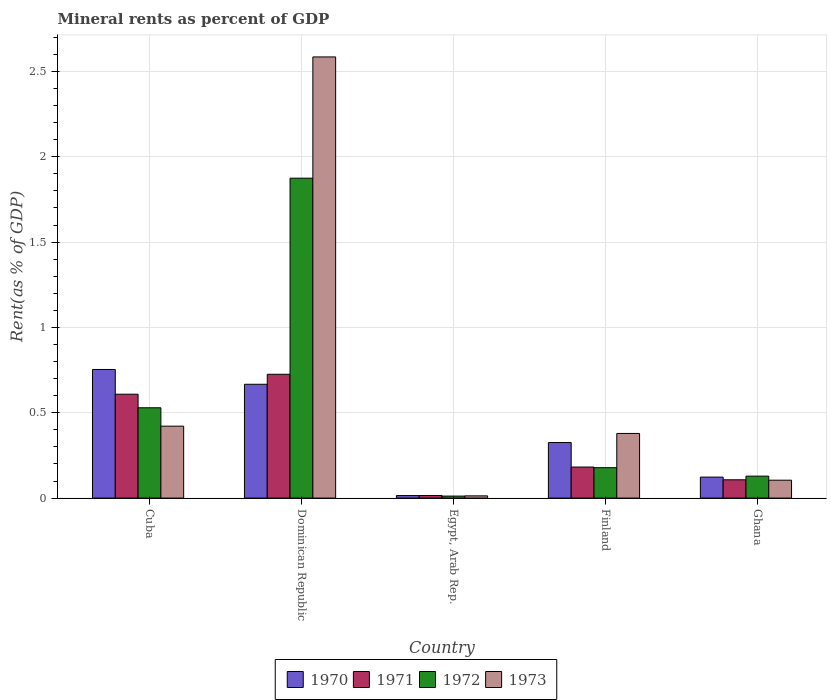How many bars are there on the 3rd tick from the left?
Your response must be concise. 4. How many bars are there on the 3rd tick from the right?
Your answer should be compact. 4. What is the label of the 2nd group of bars from the left?
Give a very brief answer. Dominican Republic. What is the mineral rent in 1972 in Cuba?
Keep it short and to the point. 0.53. Across all countries, what is the maximum mineral rent in 1970?
Offer a very short reply. 0.75. Across all countries, what is the minimum mineral rent in 1971?
Your response must be concise. 0.02. In which country was the mineral rent in 1971 maximum?
Give a very brief answer. Dominican Republic. In which country was the mineral rent in 1973 minimum?
Your answer should be very brief. Egypt, Arab Rep. What is the total mineral rent in 1972 in the graph?
Ensure brevity in your answer.  2.72. What is the difference between the mineral rent in 1970 in Finland and that in Ghana?
Your answer should be very brief. 0.2. What is the difference between the mineral rent in 1973 in Dominican Republic and the mineral rent in 1971 in Finland?
Offer a very short reply. 2.4. What is the average mineral rent in 1972 per country?
Offer a very short reply. 0.54. What is the difference between the mineral rent of/in 1973 and mineral rent of/in 1972 in Ghana?
Ensure brevity in your answer.  -0.02. In how many countries, is the mineral rent in 1972 greater than 0.5 %?
Keep it short and to the point. 2. What is the ratio of the mineral rent in 1972 in Egypt, Arab Rep. to that in Finland?
Ensure brevity in your answer.  0.07. What is the difference between the highest and the second highest mineral rent in 1971?
Provide a short and direct response. 0.12. What is the difference between the highest and the lowest mineral rent in 1970?
Provide a short and direct response. 0.74. Is the sum of the mineral rent in 1970 in Dominican Republic and Ghana greater than the maximum mineral rent in 1971 across all countries?
Your answer should be compact. Yes. Is it the case that in every country, the sum of the mineral rent in 1972 and mineral rent in 1971 is greater than the sum of mineral rent in 1973 and mineral rent in 1970?
Provide a short and direct response. No. Is it the case that in every country, the sum of the mineral rent in 1970 and mineral rent in 1973 is greater than the mineral rent in 1971?
Make the answer very short. Yes. How many bars are there?
Provide a succinct answer. 20. What is the difference between two consecutive major ticks on the Y-axis?
Give a very brief answer. 0.5. Where does the legend appear in the graph?
Offer a very short reply. Bottom center. How many legend labels are there?
Your answer should be very brief. 4. How are the legend labels stacked?
Provide a short and direct response. Horizontal. What is the title of the graph?
Make the answer very short. Mineral rents as percent of GDP. What is the label or title of the Y-axis?
Your answer should be compact. Rent(as % of GDP). What is the Rent(as % of GDP) in 1970 in Cuba?
Give a very brief answer. 0.75. What is the Rent(as % of GDP) in 1971 in Cuba?
Provide a short and direct response. 0.61. What is the Rent(as % of GDP) of 1972 in Cuba?
Offer a terse response. 0.53. What is the Rent(as % of GDP) of 1973 in Cuba?
Your answer should be very brief. 0.42. What is the Rent(as % of GDP) in 1970 in Dominican Republic?
Provide a succinct answer. 0.67. What is the Rent(as % of GDP) of 1971 in Dominican Republic?
Your answer should be very brief. 0.73. What is the Rent(as % of GDP) in 1972 in Dominican Republic?
Your answer should be compact. 1.87. What is the Rent(as % of GDP) in 1973 in Dominican Republic?
Offer a very short reply. 2.59. What is the Rent(as % of GDP) in 1970 in Egypt, Arab Rep.?
Ensure brevity in your answer.  0.01. What is the Rent(as % of GDP) of 1971 in Egypt, Arab Rep.?
Ensure brevity in your answer.  0.02. What is the Rent(as % of GDP) of 1972 in Egypt, Arab Rep.?
Your response must be concise. 0.01. What is the Rent(as % of GDP) of 1973 in Egypt, Arab Rep.?
Ensure brevity in your answer.  0.01. What is the Rent(as % of GDP) of 1970 in Finland?
Offer a very short reply. 0.33. What is the Rent(as % of GDP) of 1971 in Finland?
Make the answer very short. 0.18. What is the Rent(as % of GDP) of 1972 in Finland?
Offer a very short reply. 0.18. What is the Rent(as % of GDP) in 1973 in Finland?
Provide a short and direct response. 0.38. What is the Rent(as % of GDP) of 1970 in Ghana?
Your response must be concise. 0.12. What is the Rent(as % of GDP) of 1971 in Ghana?
Provide a short and direct response. 0.11. What is the Rent(as % of GDP) of 1972 in Ghana?
Ensure brevity in your answer.  0.13. What is the Rent(as % of GDP) of 1973 in Ghana?
Your response must be concise. 0.1. Across all countries, what is the maximum Rent(as % of GDP) of 1970?
Keep it short and to the point. 0.75. Across all countries, what is the maximum Rent(as % of GDP) in 1971?
Make the answer very short. 0.73. Across all countries, what is the maximum Rent(as % of GDP) in 1972?
Your answer should be very brief. 1.87. Across all countries, what is the maximum Rent(as % of GDP) in 1973?
Your answer should be very brief. 2.59. Across all countries, what is the minimum Rent(as % of GDP) of 1970?
Keep it short and to the point. 0.01. Across all countries, what is the minimum Rent(as % of GDP) of 1971?
Offer a very short reply. 0.02. Across all countries, what is the minimum Rent(as % of GDP) of 1972?
Your answer should be compact. 0.01. Across all countries, what is the minimum Rent(as % of GDP) of 1973?
Keep it short and to the point. 0.01. What is the total Rent(as % of GDP) in 1970 in the graph?
Offer a terse response. 1.88. What is the total Rent(as % of GDP) in 1971 in the graph?
Your answer should be very brief. 1.64. What is the total Rent(as % of GDP) of 1972 in the graph?
Offer a very short reply. 2.72. What is the total Rent(as % of GDP) in 1973 in the graph?
Give a very brief answer. 3.5. What is the difference between the Rent(as % of GDP) in 1970 in Cuba and that in Dominican Republic?
Ensure brevity in your answer.  0.09. What is the difference between the Rent(as % of GDP) of 1971 in Cuba and that in Dominican Republic?
Provide a short and direct response. -0.12. What is the difference between the Rent(as % of GDP) of 1972 in Cuba and that in Dominican Republic?
Your answer should be compact. -1.35. What is the difference between the Rent(as % of GDP) of 1973 in Cuba and that in Dominican Republic?
Ensure brevity in your answer.  -2.16. What is the difference between the Rent(as % of GDP) in 1970 in Cuba and that in Egypt, Arab Rep.?
Keep it short and to the point. 0.74. What is the difference between the Rent(as % of GDP) of 1971 in Cuba and that in Egypt, Arab Rep.?
Give a very brief answer. 0.59. What is the difference between the Rent(as % of GDP) in 1972 in Cuba and that in Egypt, Arab Rep.?
Provide a succinct answer. 0.52. What is the difference between the Rent(as % of GDP) in 1973 in Cuba and that in Egypt, Arab Rep.?
Your response must be concise. 0.41. What is the difference between the Rent(as % of GDP) in 1970 in Cuba and that in Finland?
Provide a succinct answer. 0.43. What is the difference between the Rent(as % of GDP) in 1971 in Cuba and that in Finland?
Provide a short and direct response. 0.43. What is the difference between the Rent(as % of GDP) of 1972 in Cuba and that in Finland?
Provide a short and direct response. 0.35. What is the difference between the Rent(as % of GDP) in 1973 in Cuba and that in Finland?
Offer a terse response. 0.04. What is the difference between the Rent(as % of GDP) of 1970 in Cuba and that in Ghana?
Make the answer very short. 0.63. What is the difference between the Rent(as % of GDP) in 1971 in Cuba and that in Ghana?
Give a very brief answer. 0.5. What is the difference between the Rent(as % of GDP) of 1972 in Cuba and that in Ghana?
Keep it short and to the point. 0.4. What is the difference between the Rent(as % of GDP) of 1973 in Cuba and that in Ghana?
Make the answer very short. 0.32. What is the difference between the Rent(as % of GDP) of 1970 in Dominican Republic and that in Egypt, Arab Rep.?
Provide a short and direct response. 0.65. What is the difference between the Rent(as % of GDP) of 1971 in Dominican Republic and that in Egypt, Arab Rep.?
Your answer should be very brief. 0.71. What is the difference between the Rent(as % of GDP) of 1972 in Dominican Republic and that in Egypt, Arab Rep.?
Keep it short and to the point. 1.86. What is the difference between the Rent(as % of GDP) in 1973 in Dominican Republic and that in Egypt, Arab Rep.?
Offer a very short reply. 2.57. What is the difference between the Rent(as % of GDP) of 1970 in Dominican Republic and that in Finland?
Your answer should be compact. 0.34. What is the difference between the Rent(as % of GDP) of 1971 in Dominican Republic and that in Finland?
Keep it short and to the point. 0.54. What is the difference between the Rent(as % of GDP) of 1972 in Dominican Republic and that in Finland?
Provide a short and direct response. 1.7. What is the difference between the Rent(as % of GDP) of 1973 in Dominican Republic and that in Finland?
Ensure brevity in your answer.  2.21. What is the difference between the Rent(as % of GDP) of 1970 in Dominican Republic and that in Ghana?
Offer a very short reply. 0.54. What is the difference between the Rent(as % of GDP) in 1971 in Dominican Republic and that in Ghana?
Your answer should be very brief. 0.62. What is the difference between the Rent(as % of GDP) of 1972 in Dominican Republic and that in Ghana?
Your answer should be compact. 1.75. What is the difference between the Rent(as % of GDP) in 1973 in Dominican Republic and that in Ghana?
Give a very brief answer. 2.48. What is the difference between the Rent(as % of GDP) of 1970 in Egypt, Arab Rep. and that in Finland?
Keep it short and to the point. -0.31. What is the difference between the Rent(as % of GDP) of 1971 in Egypt, Arab Rep. and that in Finland?
Keep it short and to the point. -0.17. What is the difference between the Rent(as % of GDP) of 1972 in Egypt, Arab Rep. and that in Finland?
Your response must be concise. -0.17. What is the difference between the Rent(as % of GDP) in 1973 in Egypt, Arab Rep. and that in Finland?
Your answer should be very brief. -0.37. What is the difference between the Rent(as % of GDP) of 1970 in Egypt, Arab Rep. and that in Ghana?
Make the answer very short. -0.11. What is the difference between the Rent(as % of GDP) of 1971 in Egypt, Arab Rep. and that in Ghana?
Provide a short and direct response. -0.09. What is the difference between the Rent(as % of GDP) of 1972 in Egypt, Arab Rep. and that in Ghana?
Give a very brief answer. -0.12. What is the difference between the Rent(as % of GDP) of 1973 in Egypt, Arab Rep. and that in Ghana?
Give a very brief answer. -0.09. What is the difference between the Rent(as % of GDP) of 1970 in Finland and that in Ghana?
Give a very brief answer. 0.2. What is the difference between the Rent(as % of GDP) of 1971 in Finland and that in Ghana?
Keep it short and to the point. 0.07. What is the difference between the Rent(as % of GDP) in 1972 in Finland and that in Ghana?
Offer a very short reply. 0.05. What is the difference between the Rent(as % of GDP) of 1973 in Finland and that in Ghana?
Give a very brief answer. 0.27. What is the difference between the Rent(as % of GDP) of 1970 in Cuba and the Rent(as % of GDP) of 1971 in Dominican Republic?
Give a very brief answer. 0.03. What is the difference between the Rent(as % of GDP) in 1970 in Cuba and the Rent(as % of GDP) in 1972 in Dominican Republic?
Provide a short and direct response. -1.12. What is the difference between the Rent(as % of GDP) of 1970 in Cuba and the Rent(as % of GDP) of 1973 in Dominican Republic?
Ensure brevity in your answer.  -1.83. What is the difference between the Rent(as % of GDP) in 1971 in Cuba and the Rent(as % of GDP) in 1972 in Dominican Republic?
Your answer should be very brief. -1.27. What is the difference between the Rent(as % of GDP) of 1971 in Cuba and the Rent(as % of GDP) of 1973 in Dominican Republic?
Provide a short and direct response. -1.98. What is the difference between the Rent(as % of GDP) of 1972 in Cuba and the Rent(as % of GDP) of 1973 in Dominican Republic?
Offer a very short reply. -2.06. What is the difference between the Rent(as % of GDP) of 1970 in Cuba and the Rent(as % of GDP) of 1971 in Egypt, Arab Rep.?
Your response must be concise. 0.74. What is the difference between the Rent(as % of GDP) of 1970 in Cuba and the Rent(as % of GDP) of 1972 in Egypt, Arab Rep.?
Keep it short and to the point. 0.74. What is the difference between the Rent(as % of GDP) in 1970 in Cuba and the Rent(as % of GDP) in 1973 in Egypt, Arab Rep.?
Keep it short and to the point. 0.74. What is the difference between the Rent(as % of GDP) in 1971 in Cuba and the Rent(as % of GDP) in 1972 in Egypt, Arab Rep.?
Keep it short and to the point. 0.6. What is the difference between the Rent(as % of GDP) in 1971 in Cuba and the Rent(as % of GDP) in 1973 in Egypt, Arab Rep.?
Give a very brief answer. 0.6. What is the difference between the Rent(as % of GDP) in 1972 in Cuba and the Rent(as % of GDP) in 1973 in Egypt, Arab Rep.?
Give a very brief answer. 0.52. What is the difference between the Rent(as % of GDP) in 1970 in Cuba and the Rent(as % of GDP) in 1971 in Finland?
Ensure brevity in your answer.  0.57. What is the difference between the Rent(as % of GDP) in 1970 in Cuba and the Rent(as % of GDP) in 1972 in Finland?
Your response must be concise. 0.58. What is the difference between the Rent(as % of GDP) of 1970 in Cuba and the Rent(as % of GDP) of 1973 in Finland?
Offer a very short reply. 0.37. What is the difference between the Rent(as % of GDP) of 1971 in Cuba and the Rent(as % of GDP) of 1972 in Finland?
Keep it short and to the point. 0.43. What is the difference between the Rent(as % of GDP) in 1971 in Cuba and the Rent(as % of GDP) in 1973 in Finland?
Provide a short and direct response. 0.23. What is the difference between the Rent(as % of GDP) of 1972 in Cuba and the Rent(as % of GDP) of 1973 in Finland?
Offer a terse response. 0.15. What is the difference between the Rent(as % of GDP) in 1970 in Cuba and the Rent(as % of GDP) in 1971 in Ghana?
Ensure brevity in your answer.  0.65. What is the difference between the Rent(as % of GDP) of 1970 in Cuba and the Rent(as % of GDP) of 1973 in Ghana?
Offer a terse response. 0.65. What is the difference between the Rent(as % of GDP) of 1971 in Cuba and the Rent(as % of GDP) of 1972 in Ghana?
Make the answer very short. 0.48. What is the difference between the Rent(as % of GDP) in 1971 in Cuba and the Rent(as % of GDP) in 1973 in Ghana?
Your answer should be compact. 0.5. What is the difference between the Rent(as % of GDP) in 1972 in Cuba and the Rent(as % of GDP) in 1973 in Ghana?
Give a very brief answer. 0.42. What is the difference between the Rent(as % of GDP) of 1970 in Dominican Republic and the Rent(as % of GDP) of 1971 in Egypt, Arab Rep.?
Provide a short and direct response. 0.65. What is the difference between the Rent(as % of GDP) of 1970 in Dominican Republic and the Rent(as % of GDP) of 1972 in Egypt, Arab Rep.?
Your answer should be compact. 0.66. What is the difference between the Rent(as % of GDP) in 1970 in Dominican Republic and the Rent(as % of GDP) in 1973 in Egypt, Arab Rep.?
Give a very brief answer. 0.65. What is the difference between the Rent(as % of GDP) of 1971 in Dominican Republic and the Rent(as % of GDP) of 1972 in Egypt, Arab Rep.?
Keep it short and to the point. 0.71. What is the difference between the Rent(as % of GDP) in 1971 in Dominican Republic and the Rent(as % of GDP) in 1973 in Egypt, Arab Rep.?
Your answer should be very brief. 0.71. What is the difference between the Rent(as % of GDP) of 1972 in Dominican Republic and the Rent(as % of GDP) of 1973 in Egypt, Arab Rep.?
Your response must be concise. 1.86. What is the difference between the Rent(as % of GDP) of 1970 in Dominican Republic and the Rent(as % of GDP) of 1971 in Finland?
Ensure brevity in your answer.  0.48. What is the difference between the Rent(as % of GDP) of 1970 in Dominican Republic and the Rent(as % of GDP) of 1972 in Finland?
Offer a terse response. 0.49. What is the difference between the Rent(as % of GDP) of 1970 in Dominican Republic and the Rent(as % of GDP) of 1973 in Finland?
Your answer should be compact. 0.29. What is the difference between the Rent(as % of GDP) in 1971 in Dominican Republic and the Rent(as % of GDP) in 1972 in Finland?
Offer a very short reply. 0.55. What is the difference between the Rent(as % of GDP) in 1971 in Dominican Republic and the Rent(as % of GDP) in 1973 in Finland?
Make the answer very short. 0.35. What is the difference between the Rent(as % of GDP) of 1972 in Dominican Republic and the Rent(as % of GDP) of 1973 in Finland?
Your answer should be very brief. 1.5. What is the difference between the Rent(as % of GDP) in 1970 in Dominican Republic and the Rent(as % of GDP) in 1971 in Ghana?
Provide a short and direct response. 0.56. What is the difference between the Rent(as % of GDP) in 1970 in Dominican Republic and the Rent(as % of GDP) in 1972 in Ghana?
Your answer should be very brief. 0.54. What is the difference between the Rent(as % of GDP) in 1970 in Dominican Republic and the Rent(as % of GDP) in 1973 in Ghana?
Provide a short and direct response. 0.56. What is the difference between the Rent(as % of GDP) in 1971 in Dominican Republic and the Rent(as % of GDP) in 1972 in Ghana?
Your response must be concise. 0.6. What is the difference between the Rent(as % of GDP) in 1971 in Dominican Republic and the Rent(as % of GDP) in 1973 in Ghana?
Offer a very short reply. 0.62. What is the difference between the Rent(as % of GDP) of 1972 in Dominican Republic and the Rent(as % of GDP) of 1973 in Ghana?
Your answer should be compact. 1.77. What is the difference between the Rent(as % of GDP) in 1970 in Egypt, Arab Rep. and the Rent(as % of GDP) in 1971 in Finland?
Ensure brevity in your answer.  -0.17. What is the difference between the Rent(as % of GDP) in 1970 in Egypt, Arab Rep. and the Rent(as % of GDP) in 1972 in Finland?
Provide a short and direct response. -0.16. What is the difference between the Rent(as % of GDP) in 1970 in Egypt, Arab Rep. and the Rent(as % of GDP) in 1973 in Finland?
Your answer should be very brief. -0.36. What is the difference between the Rent(as % of GDP) in 1971 in Egypt, Arab Rep. and the Rent(as % of GDP) in 1972 in Finland?
Provide a short and direct response. -0.16. What is the difference between the Rent(as % of GDP) in 1971 in Egypt, Arab Rep. and the Rent(as % of GDP) in 1973 in Finland?
Keep it short and to the point. -0.36. What is the difference between the Rent(as % of GDP) of 1972 in Egypt, Arab Rep. and the Rent(as % of GDP) of 1973 in Finland?
Your response must be concise. -0.37. What is the difference between the Rent(as % of GDP) in 1970 in Egypt, Arab Rep. and the Rent(as % of GDP) in 1971 in Ghana?
Your answer should be very brief. -0.09. What is the difference between the Rent(as % of GDP) of 1970 in Egypt, Arab Rep. and the Rent(as % of GDP) of 1972 in Ghana?
Your answer should be very brief. -0.11. What is the difference between the Rent(as % of GDP) in 1970 in Egypt, Arab Rep. and the Rent(as % of GDP) in 1973 in Ghana?
Provide a succinct answer. -0.09. What is the difference between the Rent(as % of GDP) in 1971 in Egypt, Arab Rep. and the Rent(as % of GDP) in 1972 in Ghana?
Ensure brevity in your answer.  -0.11. What is the difference between the Rent(as % of GDP) of 1971 in Egypt, Arab Rep. and the Rent(as % of GDP) of 1973 in Ghana?
Provide a short and direct response. -0.09. What is the difference between the Rent(as % of GDP) in 1972 in Egypt, Arab Rep. and the Rent(as % of GDP) in 1973 in Ghana?
Your answer should be compact. -0.09. What is the difference between the Rent(as % of GDP) in 1970 in Finland and the Rent(as % of GDP) in 1971 in Ghana?
Provide a succinct answer. 0.22. What is the difference between the Rent(as % of GDP) of 1970 in Finland and the Rent(as % of GDP) of 1972 in Ghana?
Your response must be concise. 0.2. What is the difference between the Rent(as % of GDP) in 1970 in Finland and the Rent(as % of GDP) in 1973 in Ghana?
Provide a succinct answer. 0.22. What is the difference between the Rent(as % of GDP) in 1971 in Finland and the Rent(as % of GDP) in 1972 in Ghana?
Provide a succinct answer. 0.05. What is the difference between the Rent(as % of GDP) in 1971 in Finland and the Rent(as % of GDP) in 1973 in Ghana?
Your answer should be very brief. 0.08. What is the difference between the Rent(as % of GDP) of 1972 in Finland and the Rent(as % of GDP) of 1973 in Ghana?
Provide a succinct answer. 0.07. What is the average Rent(as % of GDP) of 1970 per country?
Give a very brief answer. 0.38. What is the average Rent(as % of GDP) of 1971 per country?
Keep it short and to the point. 0.33. What is the average Rent(as % of GDP) of 1972 per country?
Offer a very short reply. 0.54. What is the average Rent(as % of GDP) in 1973 per country?
Provide a succinct answer. 0.7. What is the difference between the Rent(as % of GDP) in 1970 and Rent(as % of GDP) in 1971 in Cuba?
Ensure brevity in your answer.  0.14. What is the difference between the Rent(as % of GDP) of 1970 and Rent(as % of GDP) of 1972 in Cuba?
Offer a very short reply. 0.22. What is the difference between the Rent(as % of GDP) of 1970 and Rent(as % of GDP) of 1973 in Cuba?
Keep it short and to the point. 0.33. What is the difference between the Rent(as % of GDP) in 1971 and Rent(as % of GDP) in 1972 in Cuba?
Ensure brevity in your answer.  0.08. What is the difference between the Rent(as % of GDP) of 1971 and Rent(as % of GDP) of 1973 in Cuba?
Ensure brevity in your answer.  0.19. What is the difference between the Rent(as % of GDP) in 1972 and Rent(as % of GDP) in 1973 in Cuba?
Keep it short and to the point. 0.11. What is the difference between the Rent(as % of GDP) of 1970 and Rent(as % of GDP) of 1971 in Dominican Republic?
Your answer should be very brief. -0.06. What is the difference between the Rent(as % of GDP) of 1970 and Rent(as % of GDP) of 1972 in Dominican Republic?
Make the answer very short. -1.21. What is the difference between the Rent(as % of GDP) in 1970 and Rent(as % of GDP) in 1973 in Dominican Republic?
Keep it short and to the point. -1.92. What is the difference between the Rent(as % of GDP) of 1971 and Rent(as % of GDP) of 1972 in Dominican Republic?
Your answer should be compact. -1.15. What is the difference between the Rent(as % of GDP) of 1971 and Rent(as % of GDP) of 1973 in Dominican Republic?
Offer a terse response. -1.86. What is the difference between the Rent(as % of GDP) in 1972 and Rent(as % of GDP) in 1973 in Dominican Republic?
Make the answer very short. -0.71. What is the difference between the Rent(as % of GDP) in 1970 and Rent(as % of GDP) in 1971 in Egypt, Arab Rep.?
Give a very brief answer. -0. What is the difference between the Rent(as % of GDP) of 1970 and Rent(as % of GDP) of 1972 in Egypt, Arab Rep.?
Your answer should be compact. 0. What is the difference between the Rent(as % of GDP) in 1970 and Rent(as % of GDP) in 1973 in Egypt, Arab Rep.?
Make the answer very short. 0. What is the difference between the Rent(as % of GDP) in 1971 and Rent(as % of GDP) in 1972 in Egypt, Arab Rep.?
Provide a short and direct response. 0. What is the difference between the Rent(as % of GDP) of 1971 and Rent(as % of GDP) of 1973 in Egypt, Arab Rep.?
Your response must be concise. 0. What is the difference between the Rent(as % of GDP) of 1972 and Rent(as % of GDP) of 1973 in Egypt, Arab Rep.?
Keep it short and to the point. -0. What is the difference between the Rent(as % of GDP) of 1970 and Rent(as % of GDP) of 1971 in Finland?
Ensure brevity in your answer.  0.14. What is the difference between the Rent(as % of GDP) of 1970 and Rent(as % of GDP) of 1972 in Finland?
Ensure brevity in your answer.  0.15. What is the difference between the Rent(as % of GDP) in 1970 and Rent(as % of GDP) in 1973 in Finland?
Your answer should be very brief. -0.05. What is the difference between the Rent(as % of GDP) in 1971 and Rent(as % of GDP) in 1972 in Finland?
Keep it short and to the point. 0. What is the difference between the Rent(as % of GDP) of 1971 and Rent(as % of GDP) of 1973 in Finland?
Your response must be concise. -0.2. What is the difference between the Rent(as % of GDP) in 1972 and Rent(as % of GDP) in 1973 in Finland?
Make the answer very short. -0.2. What is the difference between the Rent(as % of GDP) of 1970 and Rent(as % of GDP) of 1971 in Ghana?
Provide a succinct answer. 0.02. What is the difference between the Rent(as % of GDP) of 1970 and Rent(as % of GDP) of 1972 in Ghana?
Provide a succinct answer. -0.01. What is the difference between the Rent(as % of GDP) in 1970 and Rent(as % of GDP) in 1973 in Ghana?
Your answer should be compact. 0.02. What is the difference between the Rent(as % of GDP) of 1971 and Rent(as % of GDP) of 1972 in Ghana?
Keep it short and to the point. -0.02. What is the difference between the Rent(as % of GDP) in 1971 and Rent(as % of GDP) in 1973 in Ghana?
Make the answer very short. 0. What is the difference between the Rent(as % of GDP) of 1972 and Rent(as % of GDP) of 1973 in Ghana?
Give a very brief answer. 0.02. What is the ratio of the Rent(as % of GDP) in 1970 in Cuba to that in Dominican Republic?
Give a very brief answer. 1.13. What is the ratio of the Rent(as % of GDP) in 1971 in Cuba to that in Dominican Republic?
Ensure brevity in your answer.  0.84. What is the ratio of the Rent(as % of GDP) of 1972 in Cuba to that in Dominican Republic?
Ensure brevity in your answer.  0.28. What is the ratio of the Rent(as % of GDP) of 1973 in Cuba to that in Dominican Republic?
Provide a succinct answer. 0.16. What is the ratio of the Rent(as % of GDP) of 1970 in Cuba to that in Egypt, Arab Rep.?
Give a very brief answer. 51. What is the ratio of the Rent(as % of GDP) in 1971 in Cuba to that in Egypt, Arab Rep.?
Give a very brief answer. 40.5. What is the ratio of the Rent(as % of GDP) in 1972 in Cuba to that in Egypt, Arab Rep.?
Provide a succinct answer. 45.11. What is the ratio of the Rent(as % of GDP) of 1973 in Cuba to that in Egypt, Arab Rep.?
Your answer should be very brief. 32.3. What is the ratio of the Rent(as % of GDP) of 1970 in Cuba to that in Finland?
Offer a terse response. 2.32. What is the ratio of the Rent(as % of GDP) in 1971 in Cuba to that in Finland?
Make the answer very short. 3.34. What is the ratio of the Rent(as % of GDP) of 1972 in Cuba to that in Finland?
Ensure brevity in your answer.  2.97. What is the ratio of the Rent(as % of GDP) in 1973 in Cuba to that in Finland?
Your answer should be compact. 1.11. What is the ratio of the Rent(as % of GDP) in 1970 in Cuba to that in Ghana?
Offer a terse response. 6.13. What is the ratio of the Rent(as % of GDP) of 1971 in Cuba to that in Ghana?
Offer a terse response. 5.68. What is the ratio of the Rent(as % of GDP) in 1972 in Cuba to that in Ghana?
Offer a very short reply. 4.11. What is the ratio of the Rent(as % of GDP) of 1973 in Cuba to that in Ghana?
Your answer should be compact. 4.02. What is the ratio of the Rent(as % of GDP) of 1970 in Dominican Republic to that in Egypt, Arab Rep.?
Your answer should be compact. 45.13. What is the ratio of the Rent(as % of GDP) of 1971 in Dominican Republic to that in Egypt, Arab Rep.?
Offer a terse response. 48.27. What is the ratio of the Rent(as % of GDP) of 1972 in Dominican Republic to that in Egypt, Arab Rep.?
Your answer should be very brief. 159.8. What is the ratio of the Rent(as % of GDP) in 1973 in Dominican Republic to that in Egypt, Arab Rep.?
Ensure brevity in your answer.  198.1. What is the ratio of the Rent(as % of GDP) of 1970 in Dominican Republic to that in Finland?
Your response must be concise. 2.05. What is the ratio of the Rent(as % of GDP) of 1971 in Dominican Republic to that in Finland?
Offer a terse response. 3.99. What is the ratio of the Rent(as % of GDP) of 1972 in Dominican Republic to that in Finland?
Ensure brevity in your answer.  10.53. What is the ratio of the Rent(as % of GDP) of 1973 in Dominican Republic to that in Finland?
Your answer should be compact. 6.82. What is the ratio of the Rent(as % of GDP) of 1970 in Dominican Republic to that in Ghana?
Your answer should be very brief. 5.42. What is the ratio of the Rent(as % of GDP) in 1971 in Dominican Republic to that in Ghana?
Your response must be concise. 6.77. What is the ratio of the Rent(as % of GDP) in 1972 in Dominican Republic to that in Ghana?
Your answer should be very brief. 14.57. What is the ratio of the Rent(as % of GDP) in 1973 in Dominican Republic to that in Ghana?
Give a very brief answer. 24.64. What is the ratio of the Rent(as % of GDP) of 1970 in Egypt, Arab Rep. to that in Finland?
Keep it short and to the point. 0.05. What is the ratio of the Rent(as % of GDP) in 1971 in Egypt, Arab Rep. to that in Finland?
Your answer should be compact. 0.08. What is the ratio of the Rent(as % of GDP) in 1972 in Egypt, Arab Rep. to that in Finland?
Provide a succinct answer. 0.07. What is the ratio of the Rent(as % of GDP) in 1973 in Egypt, Arab Rep. to that in Finland?
Offer a very short reply. 0.03. What is the ratio of the Rent(as % of GDP) in 1970 in Egypt, Arab Rep. to that in Ghana?
Offer a terse response. 0.12. What is the ratio of the Rent(as % of GDP) of 1971 in Egypt, Arab Rep. to that in Ghana?
Offer a terse response. 0.14. What is the ratio of the Rent(as % of GDP) of 1972 in Egypt, Arab Rep. to that in Ghana?
Your response must be concise. 0.09. What is the ratio of the Rent(as % of GDP) in 1973 in Egypt, Arab Rep. to that in Ghana?
Give a very brief answer. 0.12. What is the ratio of the Rent(as % of GDP) of 1970 in Finland to that in Ghana?
Your answer should be very brief. 2.65. What is the ratio of the Rent(as % of GDP) in 1971 in Finland to that in Ghana?
Offer a terse response. 1.7. What is the ratio of the Rent(as % of GDP) in 1972 in Finland to that in Ghana?
Ensure brevity in your answer.  1.38. What is the ratio of the Rent(as % of GDP) of 1973 in Finland to that in Ghana?
Give a very brief answer. 3.61. What is the difference between the highest and the second highest Rent(as % of GDP) of 1970?
Provide a short and direct response. 0.09. What is the difference between the highest and the second highest Rent(as % of GDP) of 1971?
Make the answer very short. 0.12. What is the difference between the highest and the second highest Rent(as % of GDP) of 1972?
Give a very brief answer. 1.35. What is the difference between the highest and the second highest Rent(as % of GDP) in 1973?
Your answer should be compact. 2.16. What is the difference between the highest and the lowest Rent(as % of GDP) of 1970?
Provide a short and direct response. 0.74. What is the difference between the highest and the lowest Rent(as % of GDP) in 1971?
Offer a terse response. 0.71. What is the difference between the highest and the lowest Rent(as % of GDP) of 1972?
Your answer should be very brief. 1.86. What is the difference between the highest and the lowest Rent(as % of GDP) of 1973?
Provide a short and direct response. 2.57. 